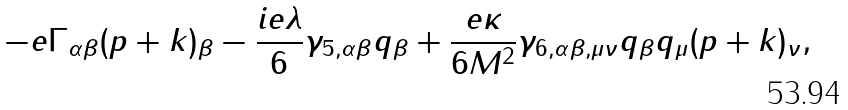<formula> <loc_0><loc_0><loc_500><loc_500>- e \Gamma _ { \alpha \beta } ( p + k ) _ { \beta } - \frac { i e \lambda } { 6 } \gamma _ { 5 , \alpha \beta } q _ { \beta } + \frac { e \kappa } { 6 M ^ { 2 } } \gamma _ { 6 , \alpha \beta , \mu \nu } q _ { \beta } q _ { \mu } ( p + k ) _ { \nu } ,</formula> 